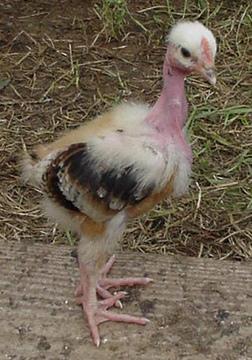Why aren't there any feathers on its neck?
Quick response, please. No. What type of bird is in the picture?
Quick response, please. Chicken. What color is the bird?
Be succinct. White. What kind of bird is it?
Concise answer only. Ostrich. Can the duck see his reflection?
Keep it brief. No. How many different colors are the animals in the picture?
Give a very brief answer. 3. Is this bird domesticated?
Answer briefly. Yes. What color are the birds?
Short answer required. White and black. What is wrong with the duck's leg?
Be succinct. Nothing. Do you see water?
Keep it brief. No. Is the bird flying?
Keep it brief. No. What color is this bird?
Answer briefly. Brown. 